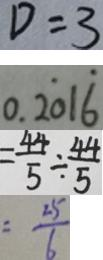<formula> <loc_0><loc_0><loc_500><loc_500>D = 3 
 0 . 2 \dot { 0 } 1 \dot { 6 } 
 = \frac { 4 4 } { 5 } \div \frac { 4 4 } { 5 } 
 = \frac { 2 5 } { 6 }</formula> 